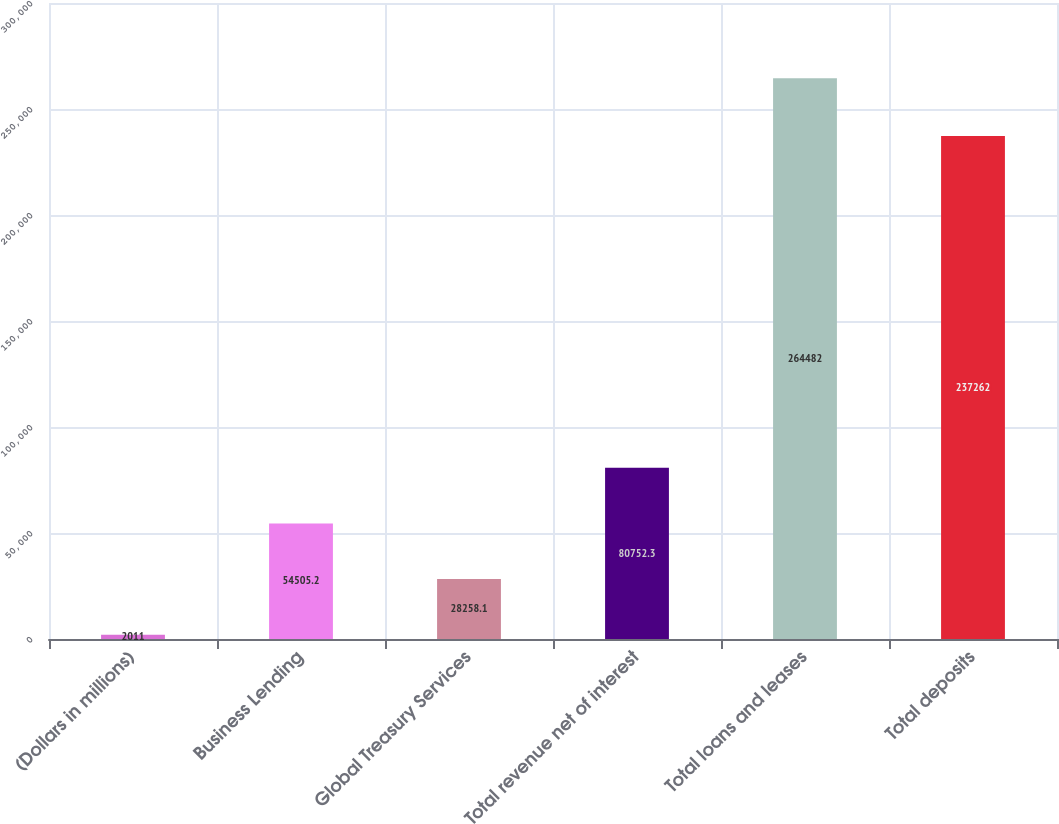<chart> <loc_0><loc_0><loc_500><loc_500><bar_chart><fcel>(Dollars in millions)<fcel>Business Lending<fcel>Global Treasury Services<fcel>Total revenue net of interest<fcel>Total loans and leases<fcel>Total deposits<nl><fcel>2011<fcel>54505.2<fcel>28258.1<fcel>80752.3<fcel>264482<fcel>237262<nl></chart> 